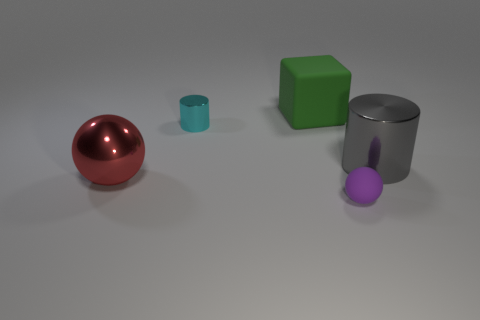What is the color of the big object that is both behind the large red object and in front of the cube?
Give a very brief answer. Gray. There is a thing that is right of the purple matte object; what shape is it?
Offer a terse response. Cylinder. What shape is the small purple object that is made of the same material as the large green block?
Your response must be concise. Sphere. What number of matte things are either big red things or large things?
Provide a succinct answer. 1. How many objects are in front of the tiny thing in front of the small object that is behind the large gray cylinder?
Keep it short and to the point. 0. Do the rubber object that is on the right side of the large block and the metal cylinder that is to the left of the green object have the same size?
Offer a terse response. Yes. There is a purple thing that is the same shape as the big red object; what is its material?
Provide a succinct answer. Rubber. How many large things are either cyan cylinders or gray metallic balls?
Make the answer very short. 0. What is the cube made of?
Provide a succinct answer. Rubber. The big thing that is on the right side of the red metallic object and left of the gray cylinder is made of what material?
Your response must be concise. Rubber. 